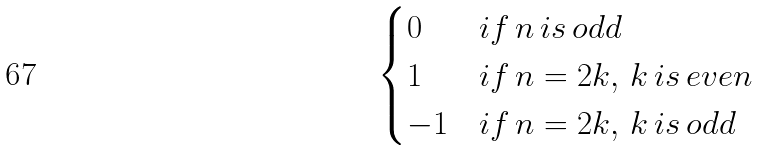Convert formula to latex. <formula><loc_0><loc_0><loc_500><loc_500>\begin{cases} 0 & i f \, n \, i s \, o d d \\ 1 & i f \, n = 2 k , \, k \, i s \, e v e n \\ - 1 & i f \, n = 2 k , \, k \, i s \, o d d \end{cases}</formula> 